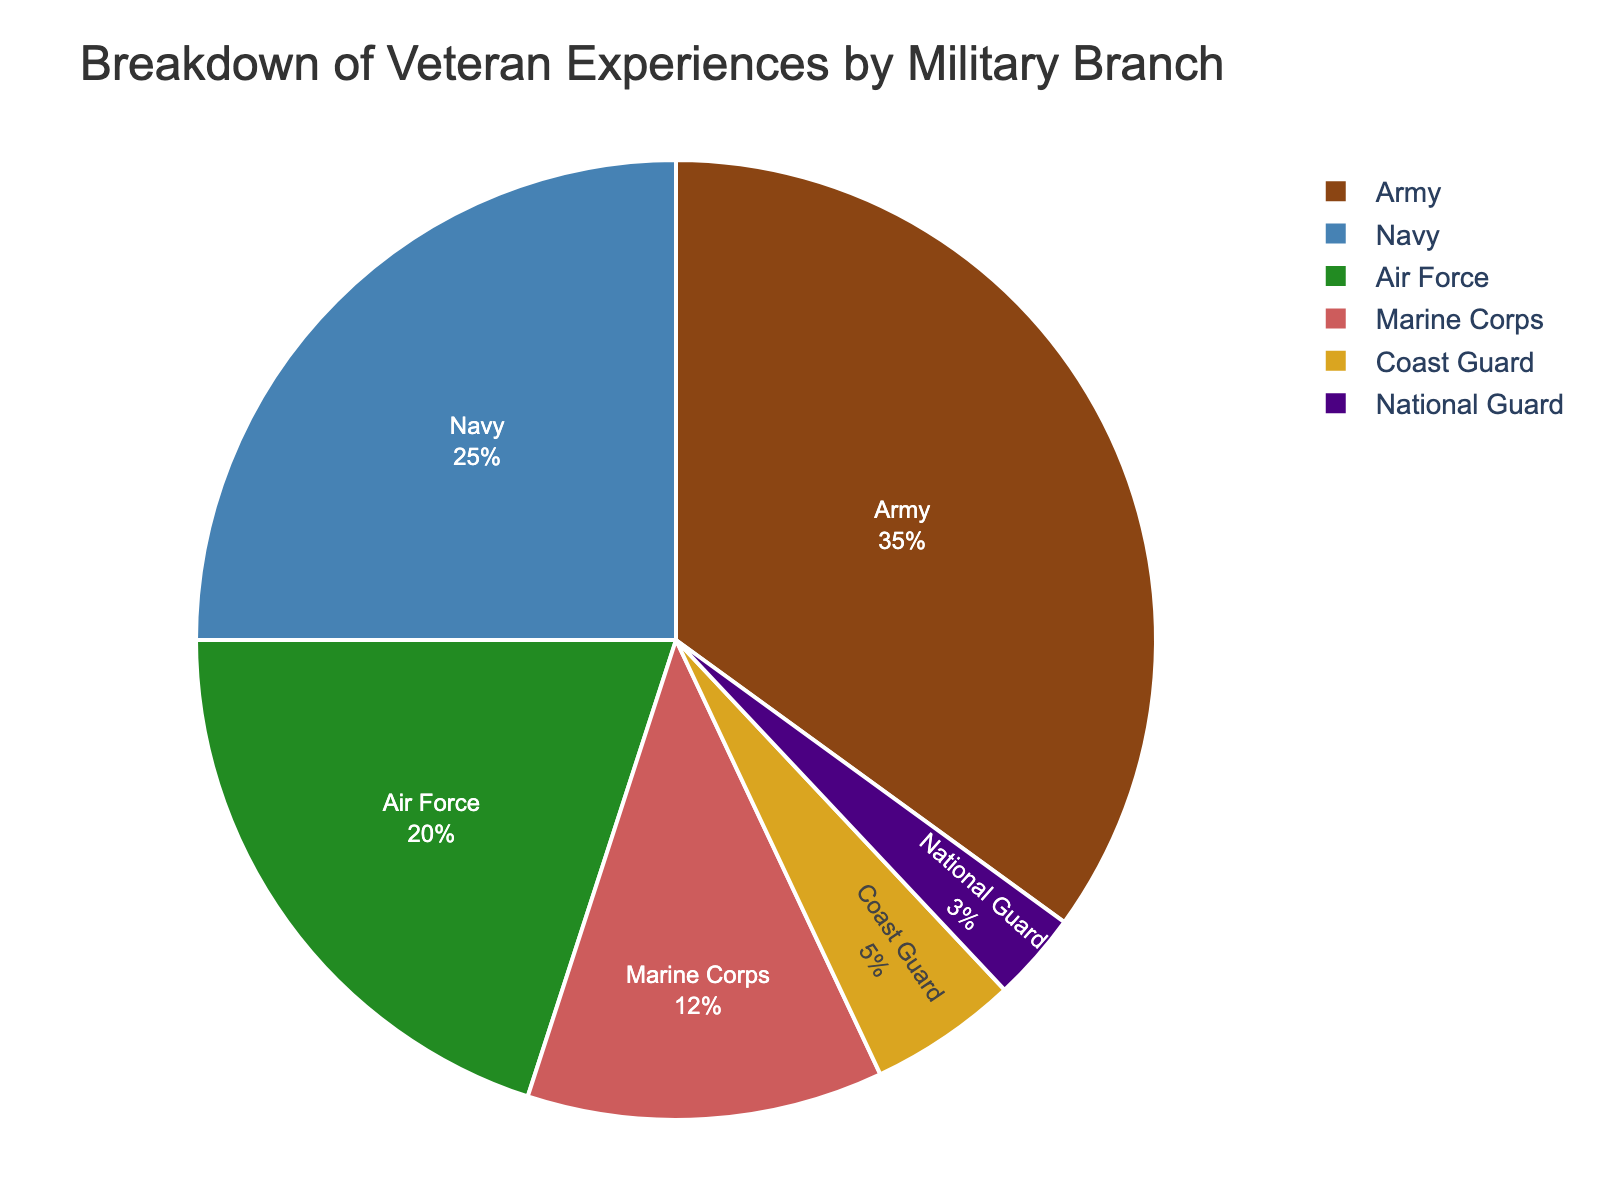What percentage of veterans served in the Navy? The pie chart shows the breakdown of veteran experiences by military branch, with a segment representing the Navy. By looking at the labeled percentages, the portion corresponding to the Navy is 25%.
Answer: 25% Which branch has the smallest representation of veterans? By observing the pie chart, the smallest segment corresponds to the National Guard at 3%.
Answer: National Guard What is the combined percentage of veterans who served in the Marine Corps and Coast Guard? Identify the segments for Marine Corps and Coast Guard. The Marine Corps has 12% and the Coast Guard has 5%. Adding these together gives 12% + 5% = 17%.
Answer: 17% Which branch has a greater percentage of veterans, Air Force or Coast Guard? Compare the segments for Air Force and Coast Guard. The Air Force segment shows 20%, while the Coast Guard segment shows 5%. Therefore, the Air Force has a greater percentage of veterans than the Coast Guard.
Answer: Air Force By how much does the Army's percentage exceed the Marine Corps' percentage? The pie chart indicates that the Army accounts for 35% and the Marine Corps accounts for 12%. Subtract the Marine Corps' percentage from the Army's percentage: 35% - 12% = 23%.
Answer: 23% What is the combined percentage of veterans who served in the Army, Navy, and Air Force? Identify the segments for Army, Navy, and Air Force. They account for 35%, 25%, and 20% respectively. Adding these together gives 35% + 25% + 20% = 80%.
Answer: 80% Which branch has the second largest representation of veterans? Examine the pie chart segments for their sizes. The Army (35%) has the largest, and the Navy (25%) has the second largest representation.
Answer: Navy How much larger is the percentage of Army veterans compared to National Guard veterans? The Army has a representation of 35% and the National Guard has 3%. Subtract the National Guard's percentage from the Army's percentage: 35% - 3% = 32%.
Answer: 32% Which branch is represented by a green-colored segment? On the pie chart, the Air Force segment is colored green.
Answer: Air Force 